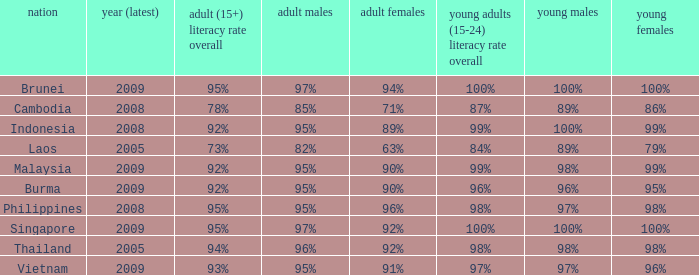Which country has its most recent year as being 2005 and has an Adult Men literacy rate of 96%? Thailand. 